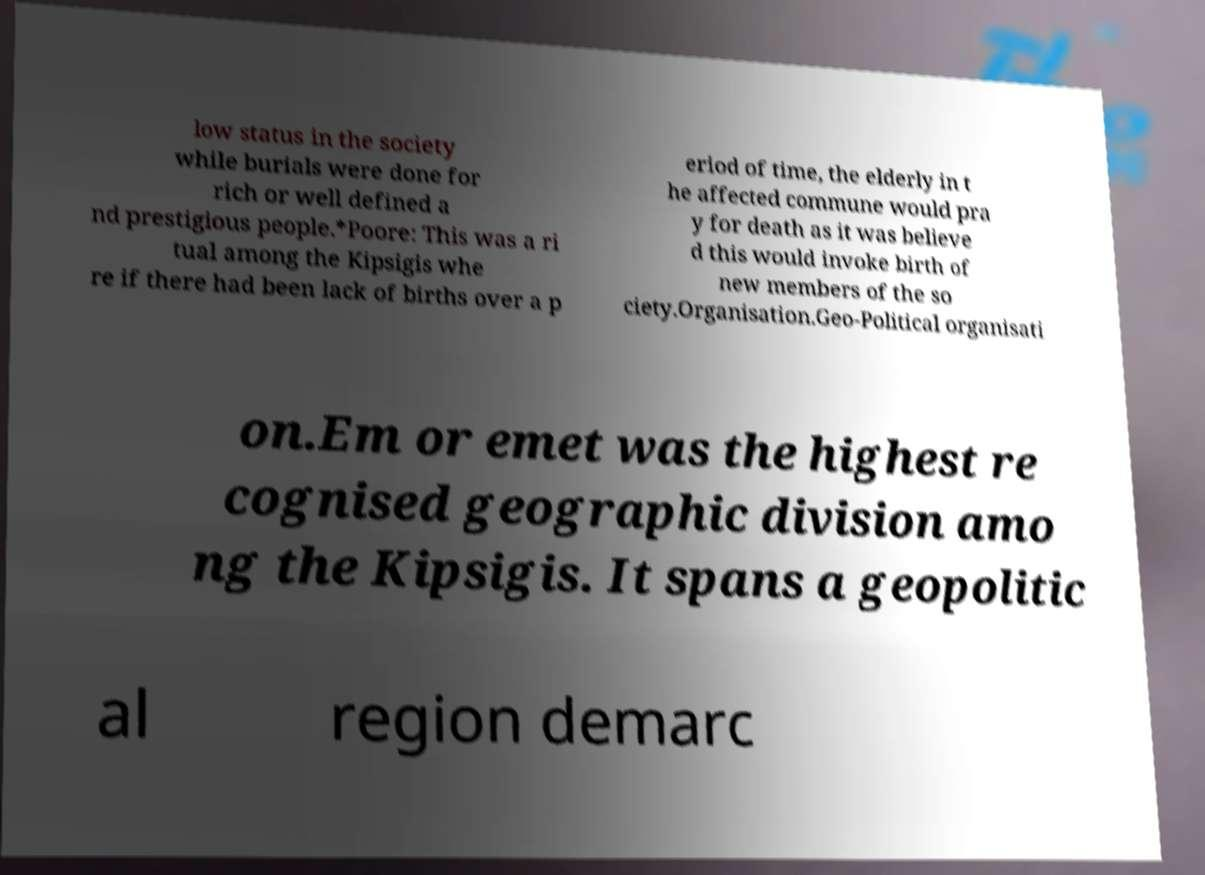There's text embedded in this image that I need extracted. Can you transcribe it verbatim? low status in the society while burials were done for rich or well defined a nd prestigious people.*Poore: This was a ri tual among the Kipsigis whe re if there had been lack of births over a p eriod of time, the elderly in t he affected commune would pra y for death as it was believe d this would invoke birth of new members of the so ciety.Organisation.Geo-Political organisati on.Em or emet was the highest re cognised geographic division amo ng the Kipsigis. It spans a geopolitic al region demarc 